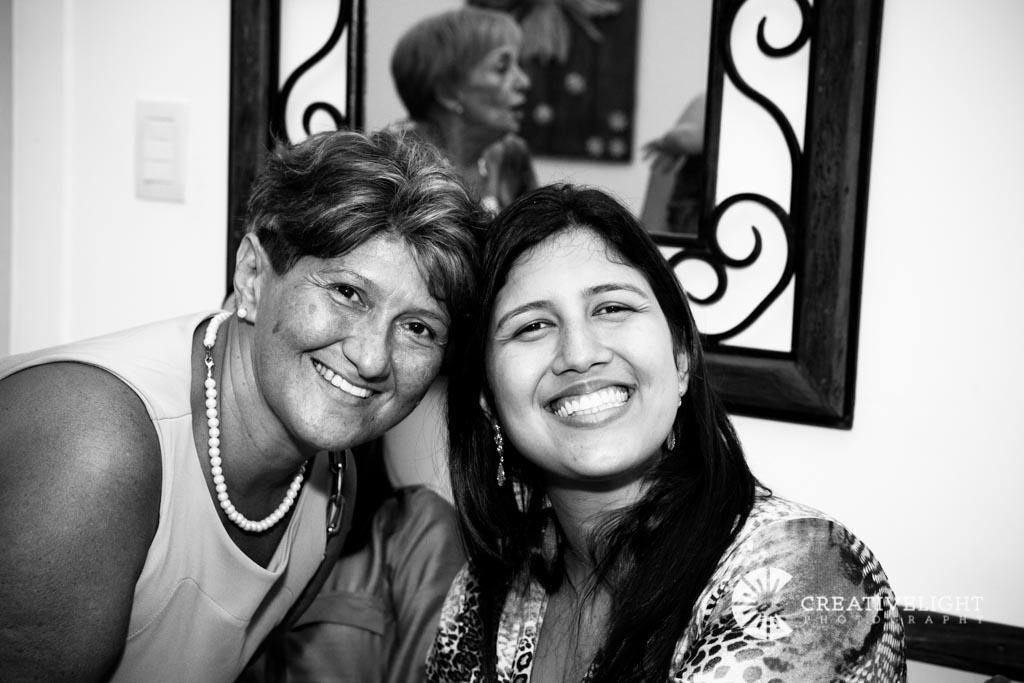How many people are present in the image? There are two people in the image. What are the people wearing? The people are wearing dresses. What expression do the people have? The people are smiling. What can be seen on the wall in the background of the image? There is a frame on the wall in the background of the image. What is the color scheme of the image? The image is black and white. Reasoning: Let's think step by step by following the guidelines step by step in order to produce the conversation. We start by identifying the main subjects in the image, which are the two people. Then, we describe their clothing and expressions. Next, we mention the frame on the wall in the background. Finally, we note the color scheme of the image, which is black and white. Absurd Question/Answer: What type of doll can be seen in the room in the image? There is no doll present in the image, and the image does not depict a room. 